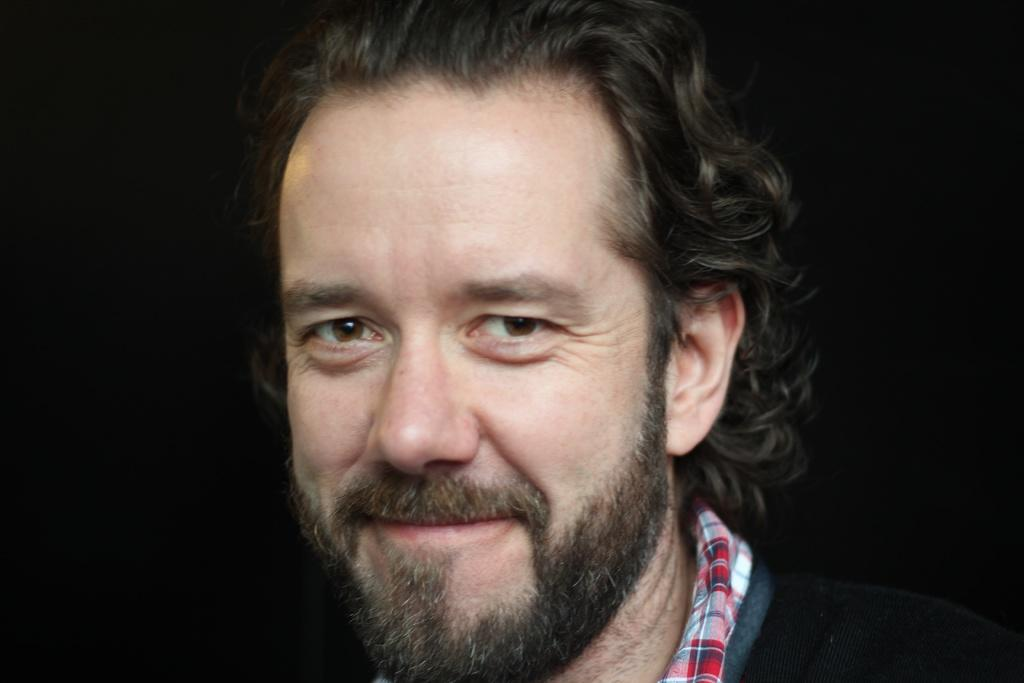What is the main subject in the foreground of the image? There is a man in the foreground of the image. Can you describe the man's facial hair? The man has a beard and a mustache. What is the man's expression in the image? The man is smiling. Where is the man standing in the image? The man appears to be standing on the ground. How would you describe the background of the image? The background of the image is very dark. What type of doctor is the man in the image? There is no indication in the image that the man is a doctor, so it cannot be determined from the picture. How many legs does the man have in the image? The man has two legs, as is typical for humans. 